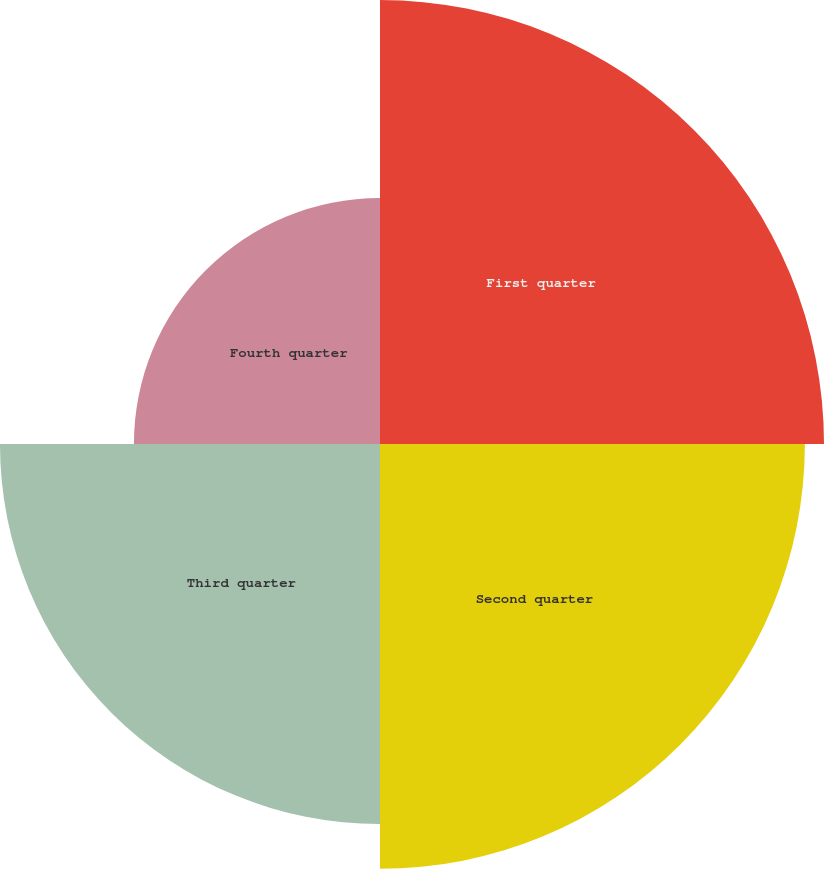Convert chart. <chart><loc_0><loc_0><loc_500><loc_500><pie_chart><fcel>First quarter<fcel>Second quarter<fcel>Third quarter<fcel>Fourth quarter<nl><fcel>29.7%<fcel>28.42%<fcel>25.42%<fcel>16.46%<nl></chart> 